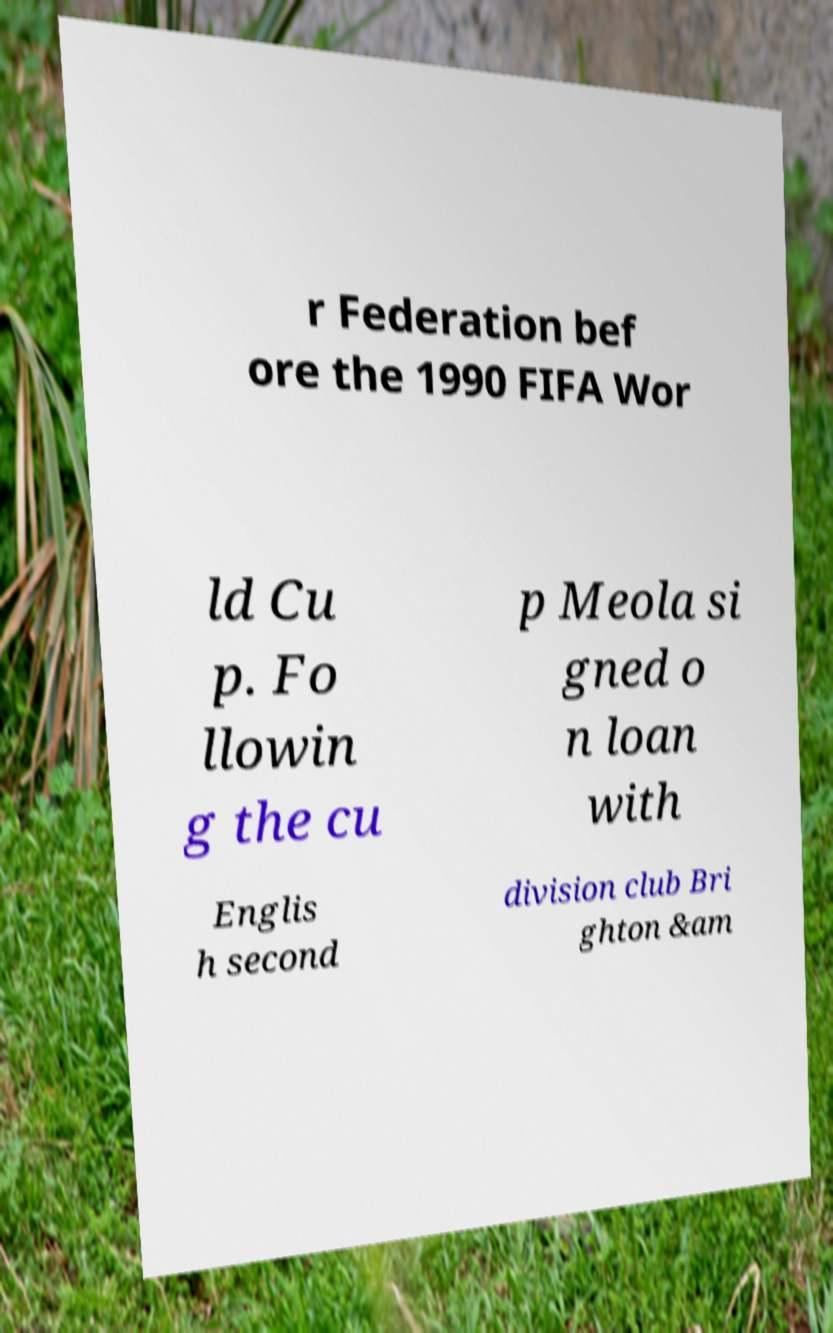Please identify and transcribe the text found in this image. r Federation bef ore the 1990 FIFA Wor ld Cu p. Fo llowin g the cu p Meola si gned o n loan with Englis h second division club Bri ghton &am 